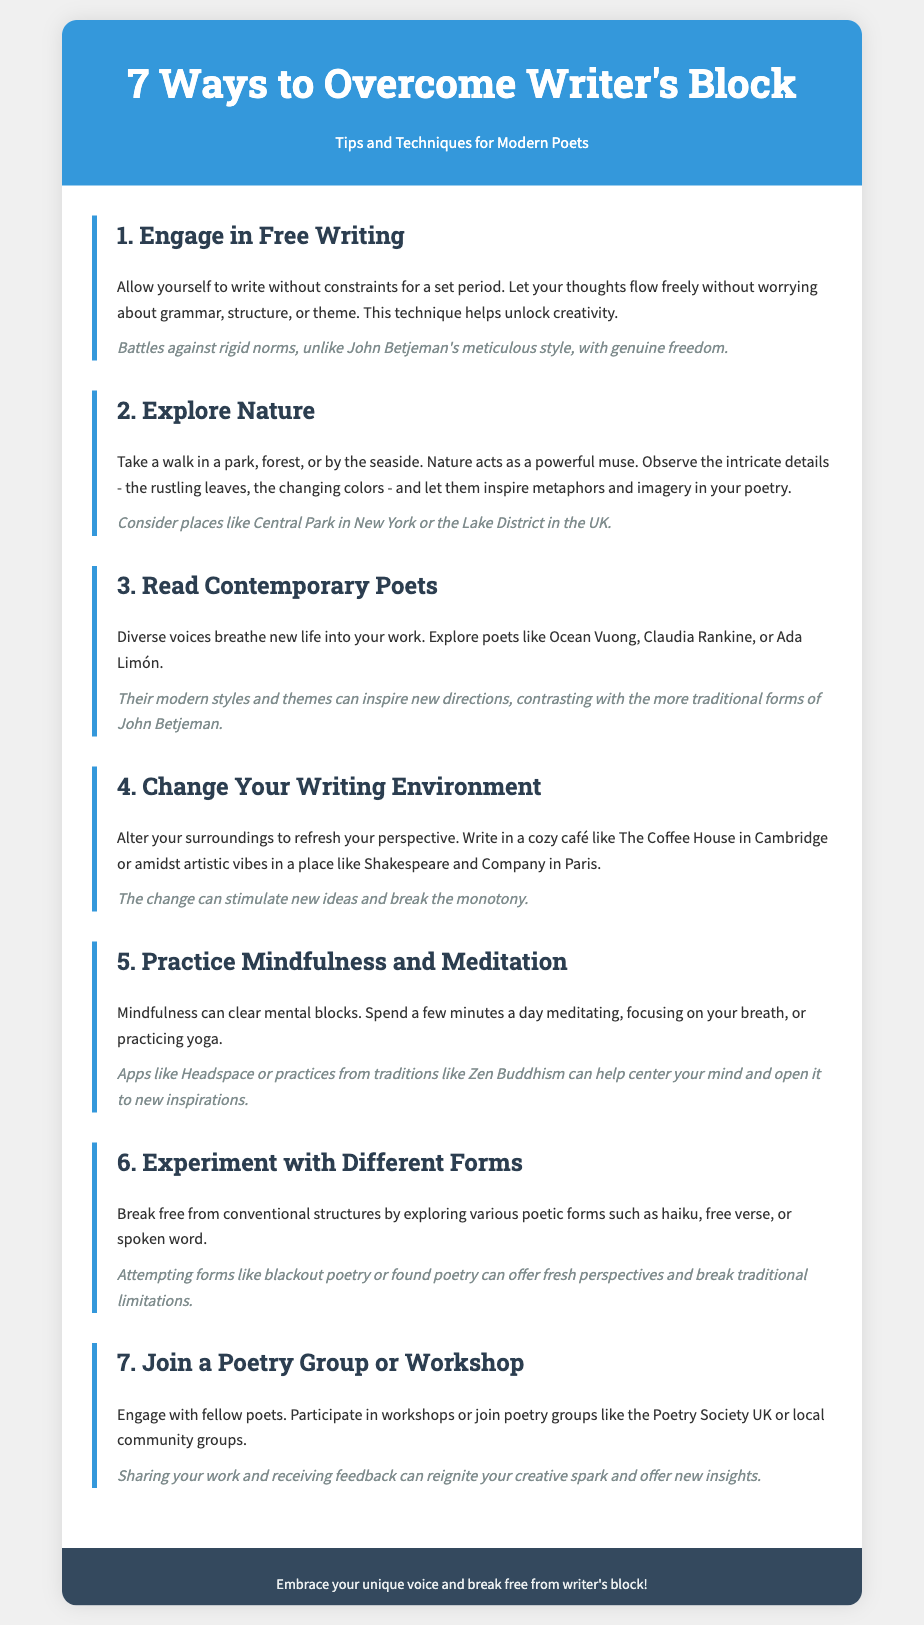What is the title of the document? The title is displayed prominently at the top of the document.
Answer: 7 Ways to Overcome Writer's Block How many tips are provided in the document? The document highlights a total of 7 distinct tips for poets.
Answer: 7 Which technique suggests engaging in writing without constraints? Referring to the first tip, it emphasizes writing freely without limitations.
Answer: Free Writing What type of writing forms can poets experiment with according to the document? The document mentions various forms of poetry that poets may explore.
Answer: Haiku, free verse, spoken word Which poets are recommended for reading to inspire creativity? The document lists specific contemporary poets as examples for inspiration.
Answer: Ocean Vuong, Claudia Rankine, Ada Limón What is the recommended environment change mentioned for refreshing perspective? The document advises altering surroundings to enhance creativity.
Answer: Cozy café What is a suggested method for clearing mental blocks? The fifth tip discusses a practice to improve mental clarity creatively.
Answer: Mindfulness and Meditation What activity can help poets share their work and receive feedback? The document addresses engagement with a community of poets as beneficial.
Answer: Join a Poetry Group or Workshop 